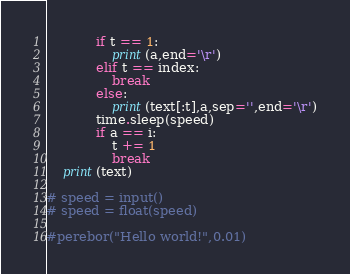<code> <loc_0><loc_0><loc_500><loc_500><_Python_>			if t == 1:
				print(a,end='\r')
			elif t == index:
				break
			else:
				print(text[:t],a,sep='',end='\r')
			time.sleep(speed)
			if a == i:
				t += 1
				break
	print(text)

# speed = input()
# speed = float(speed)

#perebor("Hello world!",0.01)
</code> 